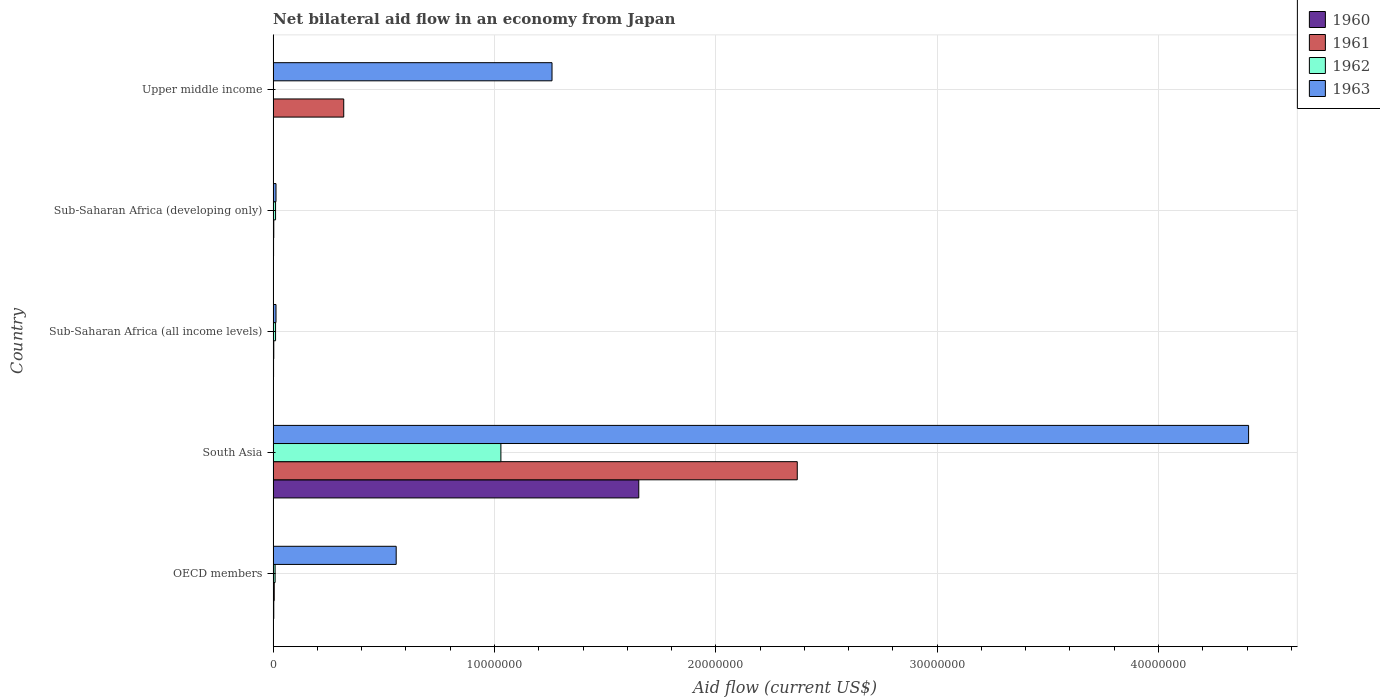How many groups of bars are there?
Make the answer very short. 5. Are the number of bars on each tick of the Y-axis equal?
Your response must be concise. No. How many bars are there on the 4th tick from the top?
Offer a very short reply. 4. What is the label of the 1st group of bars from the top?
Ensure brevity in your answer.  Upper middle income. In how many cases, is the number of bars for a given country not equal to the number of legend labels?
Your response must be concise. 1. What is the net bilateral aid flow in 1962 in Sub-Saharan Africa (developing only)?
Your answer should be compact. 1.10e+05. Across all countries, what is the maximum net bilateral aid flow in 1962?
Make the answer very short. 1.03e+07. What is the total net bilateral aid flow in 1962 in the graph?
Give a very brief answer. 1.06e+07. What is the difference between the net bilateral aid flow in 1963 in Sub-Saharan Africa (all income levels) and that in Upper middle income?
Keep it short and to the point. -1.25e+07. What is the difference between the net bilateral aid flow in 1962 in South Asia and the net bilateral aid flow in 1961 in Sub-Saharan Africa (all income levels)?
Provide a succinct answer. 1.03e+07. What is the average net bilateral aid flow in 1963 per country?
Give a very brief answer. 1.25e+07. What is the ratio of the net bilateral aid flow in 1963 in South Asia to that in Sub-Saharan Africa (all income levels)?
Offer a very short reply. 339. What is the difference between the highest and the second highest net bilateral aid flow in 1962?
Your response must be concise. 1.02e+07. What is the difference between the highest and the lowest net bilateral aid flow in 1960?
Keep it short and to the point. 1.65e+07. In how many countries, is the net bilateral aid flow in 1963 greater than the average net bilateral aid flow in 1963 taken over all countries?
Offer a very short reply. 2. Is the sum of the net bilateral aid flow in 1960 in Sub-Saharan Africa (all income levels) and Sub-Saharan Africa (developing only) greater than the maximum net bilateral aid flow in 1963 across all countries?
Make the answer very short. No. Is it the case that in every country, the sum of the net bilateral aid flow in 1963 and net bilateral aid flow in 1960 is greater than the net bilateral aid flow in 1961?
Your answer should be very brief. Yes. Where does the legend appear in the graph?
Give a very brief answer. Top right. How many legend labels are there?
Your answer should be very brief. 4. What is the title of the graph?
Your response must be concise. Net bilateral aid flow in an economy from Japan. Does "1975" appear as one of the legend labels in the graph?
Your answer should be compact. No. What is the label or title of the Y-axis?
Make the answer very short. Country. What is the Aid flow (current US$) in 1961 in OECD members?
Provide a short and direct response. 5.00e+04. What is the Aid flow (current US$) of 1962 in OECD members?
Make the answer very short. 9.00e+04. What is the Aid flow (current US$) in 1963 in OECD members?
Provide a succinct answer. 5.56e+06. What is the Aid flow (current US$) of 1960 in South Asia?
Provide a succinct answer. 1.65e+07. What is the Aid flow (current US$) in 1961 in South Asia?
Give a very brief answer. 2.37e+07. What is the Aid flow (current US$) in 1962 in South Asia?
Give a very brief answer. 1.03e+07. What is the Aid flow (current US$) in 1963 in South Asia?
Your answer should be compact. 4.41e+07. What is the Aid flow (current US$) of 1962 in Sub-Saharan Africa (all income levels)?
Provide a short and direct response. 1.10e+05. What is the Aid flow (current US$) in 1960 in Sub-Saharan Africa (developing only)?
Offer a very short reply. 2.00e+04. What is the Aid flow (current US$) of 1961 in Sub-Saharan Africa (developing only)?
Keep it short and to the point. 3.00e+04. What is the Aid flow (current US$) in 1962 in Sub-Saharan Africa (developing only)?
Offer a very short reply. 1.10e+05. What is the Aid flow (current US$) in 1963 in Sub-Saharan Africa (developing only)?
Give a very brief answer. 1.30e+05. What is the Aid flow (current US$) in 1961 in Upper middle income?
Ensure brevity in your answer.  3.19e+06. What is the Aid flow (current US$) of 1963 in Upper middle income?
Provide a succinct answer. 1.26e+07. Across all countries, what is the maximum Aid flow (current US$) in 1960?
Your response must be concise. 1.65e+07. Across all countries, what is the maximum Aid flow (current US$) in 1961?
Offer a very short reply. 2.37e+07. Across all countries, what is the maximum Aid flow (current US$) of 1962?
Your answer should be compact. 1.03e+07. Across all countries, what is the maximum Aid flow (current US$) in 1963?
Keep it short and to the point. 4.41e+07. Across all countries, what is the minimum Aid flow (current US$) in 1960?
Offer a terse response. 0. Across all countries, what is the minimum Aid flow (current US$) in 1963?
Keep it short and to the point. 1.30e+05. What is the total Aid flow (current US$) of 1960 in the graph?
Provide a short and direct response. 1.66e+07. What is the total Aid flow (current US$) in 1961 in the graph?
Keep it short and to the point. 2.70e+07. What is the total Aid flow (current US$) in 1962 in the graph?
Your answer should be very brief. 1.06e+07. What is the total Aid flow (current US$) in 1963 in the graph?
Give a very brief answer. 6.25e+07. What is the difference between the Aid flow (current US$) of 1960 in OECD members and that in South Asia?
Provide a succinct answer. -1.65e+07. What is the difference between the Aid flow (current US$) in 1961 in OECD members and that in South Asia?
Your response must be concise. -2.36e+07. What is the difference between the Aid flow (current US$) of 1962 in OECD members and that in South Asia?
Your answer should be very brief. -1.02e+07. What is the difference between the Aid flow (current US$) in 1963 in OECD members and that in South Asia?
Offer a very short reply. -3.85e+07. What is the difference between the Aid flow (current US$) of 1960 in OECD members and that in Sub-Saharan Africa (all income levels)?
Ensure brevity in your answer.  10000. What is the difference between the Aid flow (current US$) of 1961 in OECD members and that in Sub-Saharan Africa (all income levels)?
Give a very brief answer. 2.00e+04. What is the difference between the Aid flow (current US$) in 1962 in OECD members and that in Sub-Saharan Africa (all income levels)?
Ensure brevity in your answer.  -2.00e+04. What is the difference between the Aid flow (current US$) of 1963 in OECD members and that in Sub-Saharan Africa (all income levels)?
Offer a very short reply. 5.43e+06. What is the difference between the Aid flow (current US$) of 1962 in OECD members and that in Sub-Saharan Africa (developing only)?
Keep it short and to the point. -2.00e+04. What is the difference between the Aid flow (current US$) in 1963 in OECD members and that in Sub-Saharan Africa (developing only)?
Ensure brevity in your answer.  5.43e+06. What is the difference between the Aid flow (current US$) in 1961 in OECD members and that in Upper middle income?
Keep it short and to the point. -3.14e+06. What is the difference between the Aid flow (current US$) in 1963 in OECD members and that in Upper middle income?
Your answer should be compact. -7.04e+06. What is the difference between the Aid flow (current US$) in 1960 in South Asia and that in Sub-Saharan Africa (all income levels)?
Offer a very short reply. 1.65e+07. What is the difference between the Aid flow (current US$) in 1961 in South Asia and that in Sub-Saharan Africa (all income levels)?
Offer a terse response. 2.36e+07. What is the difference between the Aid flow (current US$) of 1962 in South Asia and that in Sub-Saharan Africa (all income levels)?
Provide a short and direct response. 1.02e+07. What is the difference between the Aid flow (current US$) of 1963 in South Asia and that in Sub-Saharan Africa (all income levels)?
Keep it short and to the point. 4.39e+07. What is the difference between the Aid flow (current US$) of 1960 in South Asia and that in Sub-Saharan Africa (developing only)?
Provide a short and direct response. 1.65e+07. What is the difference between the Aid flow (current US$) in 1961 in South Asia and that in Sub-Saharan Africa (developing only)?
Your answer should be very brief. 2.36e+07. What is the difference between the Aid flow (current US$) of 1962 in South Asia and that in Sub-Saharan Africa (developing only)?
Your answer should be very brief. 1.02e+07. What is the difference between the Aid flow (current US$) in 1963 in South Asia and that in Sub-Saharan Africa (developing only)?
Offer a terse response. 4.39e+07. What is the difference between the Aid flow (current US$) in 1961 in South Asia and that in Upper middle income?
Offer a terse response. 2.05e+07. What is the difference between the Aid flow (current US$) of 1963 in South Asia and that in Upper middle income?
Your response must be concise. 3.15e+07. What is the difference between the Aid flow (current US$) in 1961 in Sub-Saharan Africa (all income levels) and that in Sub-Saharan Africa (developing only)?
Offer a very short reply. 0. What is the difference between the Aid flow (current US$) in 1961 in Sub-Saharan Africa (all income levels) and that in Upper middle income?
Offer a very short reply. -3.16e+06. What is the difference between the Aid flow (current US$) of 1963 in Sub-Saharan Africa (all income levels) and that in Upper middle income?
Your answer should be compact. -1.25e+07. What is the difference between the Aid flow (current US$) of 1961 in Sub-Saharan Africa (developing only) and that in Upper middle income?
Offer a very short reply. -3.16e+06. What is the difference between the Aid flow (current US$) of 1963 in Sub-Saharan Africa (developing only) and that in Upper middle income?
Provide a short and direct response. -1.25e+07. What is the difference between the Aid flow (current US$) of 1960 in OECD members and the Aid flow (current US$) of 1961 in South Asia?
Offer a terse response. -2.36e+07. What is the difference between the Aid flow (current US$) of 1960 in OECD members and the Aid flow (current US$) of 1962 in South Asia?
Your answer should be compact. -1.03e+07. What is the difference between the Aid flow (current US$) of 1960 in OECD members and the Aid flow (current US$) of 1963 in South Asia?
Your answer should be very brief. -4.40e+07. What is the difference between the Aid flow (current US$) in 1961 in OECD members and the Aid flow (current US$) in 1962 in South Asia?
Ensure brevity in your answer.  -1.02e+07. What is the difference between the Aid flow (current US$) of 1961 in OECD members and the Aid flow (current US$) of 1963 in South Asia?
Keep it short and to the point. -4.40e+07. What is the difference between the Aid flow (current US$) in 1962 in OECD members and the Aid flow (current US$) in 1963 in South Asia?
Your answer should be compact. -4.40e+07. What is the difference between the Aid flow (current US$) of 1960 in OECD members and the Aid flow (current US$) of 1962 in Sub-Saharan Africa (all income levels)?
Your answer should be compact. -8.00e+04. What is the difference between the Aid flow (current US$) in 1961 in OECD members and the Aid flow (current US$) in 1962 in Sub-Saharan Africa (all income levels)?
Provide a short and direct response. -6.00e+04. What is the difference between the Aid flow (current US$) of 1962 in OECD members and the Aid flow (current US$) of 1963 in Sub-Saharan Africa (all income levels)?
Provide a succinct answer. -4.00e+04. What is the difference between the Aid flow (current US$) in 1960 in OECD members and the Aid flow (current US$) in 1961 in Sub-Saharan Africa (developing only)?
Make the answer very short. 0. What is the difference between the Aid flow (current US$) of 1960 in OECD members and the Aid flow (current US$) of 1962 in Sub-Saharan Africa (developing only)?
Offer a terse response. -8.00e+04. What is the difference between the Aid flow (current US$) of 1960 in OECD members and the Aid flow (current US$) of 1963 in Sub-Saharan Africa (developing only)?
Provide a short and direct response. -1.00e+05. What is the difference between the Aid flow (current US$) of 1960 in OECD members and the Aid flow (current US$) of 1961 in Upper middle income?
Provide a succinct answer. -3.16e+06. What is the difference between the Aid flow (current US$) of 1960 in OECD members and the Aid flow (current US$) of 1963 in Upper middle income?
Provide a succinct answer. -1.26e+07. What is the difference between the Aid flow (current US$) of 1961 in OECD members and the Aid flow (current US$) of 1963 in Upper middle income?
Keep it short and to the point. -1.26e+07. What is the difference between the Aid flow (current US$) of 1962 in OECD members and the Aid flow (current US$) of 1963 in Upper middle income?
Keep it short and to the point. -1.25e+07. What is the difference between the Aid flow (current US$) of 1960 in South Asia and the Aid flow (current US$) of 1961 in Sub-Saharan Africa (all income levels)?
Keep it short and to the point. 1.65e+07. What is the difference between the Aid flow (current US$) of 1960 in South Asia and the Aid flow (current US$) of 1962 in Sub-Saharan Africa (all income levels)?
Keep it short and to the point. 1.64e+07. What is the difference between the Aid flow (current US$) in 1960 in South Asia and the Aid flow (current US$) in 1963 in Sub-Saharan Africa (all income levels)?
Offer a terse response. 1.64e+07. What is the difference between the Aid flow (current US$) in 1961 in South Asia and the Aid flow (current US$) in 1962 in Sub-Saharan Africa (all income levels)?
Give a very brief answer. 2.36e+07. What is the difference between the Aid flow (current US$) in 1961 in South Asia and the Aid flow (current US$) in 1963 in Sub-Saharan Africa (all income levels)?
Provide a short and direct response. 2.36e+07. What is the difference between the Aid flow (current US$) in 1962 in South Asia and the Aid flow (current US$) in 1963 in Sub-Saharan Africa (all income levels)?
Your response must be concise. 1.02e+07. What is the difference between the Aid flow (current US$) of 1960 in South Asia and the Aid flow (current US$) of 1961 in Sub-Saharan Africa (developing only)?
Make the answer very short. 1.65e+07. What is the difference between the Aid flow (current US$) of 1960 in South Asia and the Aid flow (current US$) of 1962 in Sub-Saharan Africa (developing only)?
Offer a very short reply. 1.64e+07. What is the difference between the Aid flow (current US$) of 1960 in South Asia and the Aid flow (current US$) of 1963 in Sub-Saharan Africa (developing only)?
Offer a terse response. 1.64e+07. What is the difference between the Aid flow (current US$) of 1961 in South Asia and the Aid flow (current US$) of 1962 in Sub-Saharan Africa (developing only)?
Offer a terse response. 2.36e+07. What is the difference between the Aid flow (current US$) in 1961 in South Asia and the Aid flow (current US$) in 1963 in Sub-Saharan Africa (developing only)?
Offer a very short reply. 2.36e+07. What is the difference between the Aid flow (current US$) of 1962 in South Asia and the Aid flow (current US$) of 1963 in Sub-Saharan Africa (developing only)?
Offer a terse response. 1.02e+07. What is the difference between the Aid flow (current US$) in 1960 in South Asia and the Aid flow (current US$) in 1961 in Upper middle income?
Offer a terse response. 1.33e+07. What is the difference between the Aid flow (current US$) in 1960 in South Asia and the Aid flow (current US$) in 1963 in Upper middle income?
Keep it short and to the point. 3.92e+06. What is the difference between the Aid flow (current US$) of 1961 in South Asia and the Aid flow (current US$) of 1963 in Upper middle income?
Provide a succinct answer. 1.11e+07. What is the difference between the Aid flow (current US$) in 1962 in South Asia and the Aid flow (current US$) in 1963 in Upper middle income?
Keep it short and to the point. -2.31e+06. What is the difference between the Aid flow (current US$) of 1960 in Sub-Saharan Africa (all income levels) and the Aid flow (current US$) of 1961 in Sub-Saharan Africa (developing only)?
Provide a short and direct response. -10000. What is the difference between the Aid flow (current US$) in 1960 in Sub-Saharan Africa (all income levels) and the Aid flow (current US$) in 1961 in Upper middle income?
Ensure brevity in your answer.  -3.17e+06. What is the difference between the Aid flow (current US$) in 1960 in Sub-Saharan Africa (all income levels) and the Aid flow (current US$) in 1963 in Upper middle income?
Provide a succinct answer. -1.26e+07. What is the difference between the Aid flow (current US$) of 1961 in Sub-Saharan Africa (all income levels) and the Aid flow (current US$) of 1963 in Upper middle income?
Ensure brevity in your answer.  -1.26e+07. What is the difference between the Aid flow (current US$) in 1962 in Sub-Saharan Africa (all income levels) and the Aid flow (current US$) in 1963 in Upper middle income?
Ensure brevity in your answer.  -1.25e+07. What is the difference between the Aid flow (current US$) in 1960 in Sub-Saharan Africa (developing only) and the Aid flow (current US$) in 1961 in Upper middle income?
Offer a very short reply. -3.17e+06. What is the difference between the Aid flow (current US$) in 1960 in Sub-Saharan Africa (developing only) and the Aid flow (current US$) in 1963 in Upper middle income?
Offer a terse response. -1.26e+07. What is the difference between the Aid flow (current US$) in 1961 in Sub-Saharan Africa (developing only) and the Aid flow (current US$) in 1963 in Upper middle income?
Your answer should be compact. -1.26e+07. What is the difference between the Aid flow (current US$) of 1962 in Sub-Saharan Africa (developing only) and the Aid flow (current US$) of 1963 in Upper middle income?
Your answer should be very brief. -1.25e+07. What is the average Aid flow (current US$) in 1960 per country?
Your answer should be compact. 3.32e+06. What is the average Aid flow (current US$) of 1961 per country?
Offer a terse response. 5.40e+06. What is the average Aid flow (current US$) in 1962 per country?
Keep it short and to the point. 2.12e+06. What is the average Aid flow (current US$) in 1963 per country?
Your answer should be compact. 1.25e+07. What is the difference between the Aid flow (current US$) of 1960 and Aid flow (current US$) of 1961 in OECD members?
Keep it short and to the point. -2.00e+04. What is the difference between the Aid flow (current US$) of 1960 and Aid flow (current US$) of 1962 in OECD members?
Ensure brevity in your answer.  -6.00e+04. What is the difference between the Aid flow (current US$) of 1960 and Aid flow (current US$) of 1963 in OECD members?
Give a very brief answer. -5.53e+06. What is the difference between the Aid flow (current US$) of 1961 and Aid flow (current US$) of 1962 in OECD members?
Ensure brevity in your answer.  -4.00e+04. What is the difference between the Aid flow (current US$) of 1961 and Aid flow (current US$) of 1963 in OECD members?
Your answer should be compact. -5.51e+06. What is the difference between the Aid flow (current US$) in 1962 and Aid flow (current US$) in 1963 in OECD members?
Provide a succinct answer. -5.47e+06. What is the difference between the Aid flow (current US$) of 1960 and Aid flow (current US$) of 1961 in South Asia?
Your response must be concise. -7.16e+06. What is the difference between the Aid flow (current US$) of 1960 and Aid flow (current US$) of 1962 in South Asia?
Offer a very short reply. 6.23e+06. What is the difference between the Aid flow (current US$) in 1960 and Aid flow (current US$) in 1963 in South Asia?
Your response must be concise. -2.76e+07. What is the difference between the Aid flow (current US$) of 1961 and Aid flow (current US$) of 1962 in South Asia?
Your response must be concise. 1.34e+07. What is the difference between the Aid flow (current US$) in 1961 and Aid flow (current US$) in 1963 in South Asia?
Your answer should be very brief. -2.04e+07. What is the difference between the Aid flow (current US$) of 1962 and Aid flow (current US$) of 1963 in South Asia?
Offer a very short reply. -3.38e+07. What is the difference between the Aid flow (current US$) in 1960 and Aid flow (current US$) in 1962 in Sub-Saharan Africa (all income levels)?
Your answer should be compact. -9.00e+04. What is the difference between the Aid flow (current US$) in 1960 and Aid flow (current US$) in 1963 in Sub-Saharan Africa (all income levels)?
Ensure brevity in your answer.  -1.10e+05. What is the difference between the Aid flow (current US$) of 1962 and Aid flow (current US$) of 1963 in Sub-Saharan Africa (all income levels)?
Your answer should be very brief. -2.00e+04. What is the difference between the Aid flow (current US$) of 1960 and Aid flow (current US$) of 1961 in Sub-Saharan Africa (developing only)?
Offer a terse response. -10000. What is the difference between the Aid flow (current US$) of 1960 and Aid flow (current US$) of 1963 in Sub-Saharan Africa (developing only)?
Provide a short and direct response. -1.10e+05. What is the difference between the Aid flow (current US$) in 1961 and Aid flow (current US$) in 1962 in Sub-Saharan Africa (developing only)?
Provide a succinct answer. -8.00e+04. What is the difference between the Aid flow (current US$) in 1961 and Aid flow (current US$) in 1963 in Sub-Saharan Africa (developing only)?
Provide a succinct answer. -1.00e+05. What is the difference between the Aid flow (current US$) of 1961 and Aid flow (current US$) of 1963 in Upper middle income?
Keep it short and to the point. -9.41e+06. What is the ratio of the Aid flow (current US$) of 1960 in OECD members to that in South Asia?
Ensure brevity in your answer.  0. What is the ratio of the Aid flow (current US$) of 1961 in OECD members to that in South Asia?
Keep it short and to the point. 0. What is the ratio of the Aid flow (current US$) in 1962 in OECD members to that in South Asia?
Provide a succinct answer. 0.01. What is the ratio of the Aid flow (current US$) in 1963 in OECD members to that in South Asia?
Your response must be concise. 0.13. What is the ratio of the Aid flow (current US$) in 1960 in OECD members to that in Sub-Saharan Africa (all income levels)?
Your answer should be very brief. 1.5. What is the ratio of the Aid flow (current US$) in 1962 in OECD members to that in Sub-Saharan Africa (all income levels)?
Make the answer very short. 0.82. What is the ratio of the Aid flow (current US$) of 1963 in OECD members to that in Sub-Saharan Africa (all income levels)?
Your answer should be compact. 42.77. What is the ratio of the Aid flow (current US$) of 1960 in OECD members to that in Sub-Saharan Africa (developing only)?
Provide a short and direct response. 1.5. What is the ratio of the Aid flow (current US$) in 1962 in OECD members to that in Sub-Saharan Africa (developing only)?
Your response must be concise. 0.82. What is the ratio of the Aid flow (current US$) of 1963 in OECD members to that in Sub-Saharan Africa (developing only)?
Give a very brief answer. 42.77. What is the ratio of the Aid flow (current US$) in 1961 in OECD members to that in Upper middle income?
Your response must be concise. 0.02. What is the ratio of the Aid flow (current US$) of 1963 in OECD members to that in Upper middle income?
Ensure brevity in your answer.  0.44. What is the ratio of the Aid flow (current US$) in 1960 in South Asia to that in Sub-Saharan Africa (all income levels)?
Provide a short and direct response. 826. What is the ratio of the Aid flow (current US$) of 1961 in South Asia to that in Sub-Saharan Africa (all income levels)?
Keep it short and to the point. 789.33. What is the ratio of the Aid flow (current US$) of 1962 in South Asia to that in Sub-Saharan Africa (all income levels)?
Keep it short and to the point. 93.55. What is the ratio of the Aid flow (current US$) of 1963 in South Asia to that in Sub-Saharan Africa (all income levels)?
Your response must be concise. 339. What is the ratio of the Aid flow (current US$) of 1960 in South Asia to that in Sub-Saharan Africa (developing only)?
Your answer should be very brief. 826. What is the ratio of the Aid flow (current US$) of 1961 in South Asia to that in Sub-Saharan Africa (developing only)?
Offer a terse response. 789.33. What is the ratio of the Aid flow (current US$) in 1962 in South Asia to that in Sub-Saharan Africa (developing only)?
Your answer should be compact. 93.55. What is the ratio of the Aid flow (current US$) in 1963 in South Asia to that in Sub-Saharan Africa (developing only)?
Ensure brevity in your answer.  339. What is the ratio of the Aid flow (current US$) in 1961 in South Asia to that in Upper middle income?
Make the answer very short. 7.42. What is the ratio of the Aid flow (current US$) in 1963 in South Asia to that in Upper middle income?
Offer a terse response. 3.5. What is the ratio of the Aid flow (current US$) in 1960 in Sub-Saharan Africa (all income levels) to that in Sub-Saharan Africa (developing only)?
Give a very brief answer. 1. What is the ratio of the Aid flow (current US$) in 1961 in Sub-Saharan Africa (all income levels) to that in Sub-Saharan Africa (developing only)?
Offer a terse response. 1. What is the ratio of the Aid flow (current US$) in 1963 in Sub-Saharan Africa (all income levels) to that in Sub-Saharan Africa (developing only)?
Give a very brief answer. 1. What is the ratio of the Aid flow (current US$) of 1961 in Sub-Saharan Africa (all income levels) to that in Upper middle income?
Offer a very short reply. 0.01. What is the ratio of the Aid flow (current US$) in 1963 in Sub-Saharan Africa (all income levels) to that in Upper middle income?
Your answer should be compact. 0.01. What is the ratio of the Aid flow (current US$) of 1961 in Sub-Saharan Africa (developing only) to that in Upper middle income?
Offer a very short reply. 0.01. What is the ratio of the Aid flow (current US$) of 1963 in Sub-Saharan Africa (developing only) to that in Upper middle income?
Provide a short and direct response. 0.01. What is the difference between the highest and the second highest Aid flow (current US$) in 1960?
Provide a succinct answer. 1.65e+07. What is the difference between the highest and the second highest Aid flow (current US$) in 1961?
Your response must be concise. 2.05e+07. What is the difference between the highest and the second highest Aid flow (current US$) of 1962?
Your answer should be compact. 1.02e+07. What is the difference between the highest and the second highest Aid flow (current US$) of 1963?
Your answer should be very brief. 3.15e+07. What is the difference between the highest and the lowest Aid flow (current US$) in 1960?
Make the answer very short. 1.65e+07. What is the difference between the highest and the lowest Aid flow (current US$) of 1961?
Your response must be concise. 2.36e+07. What is the difference between the highest and the lowest Aid flow (current US$) in 1962?
Give a very brief answer. 1.03e+07. What is the difference between the highest and the lowest Aid flow (current US$) in 1963?
Give a very brief answer. 4.39e+07. 